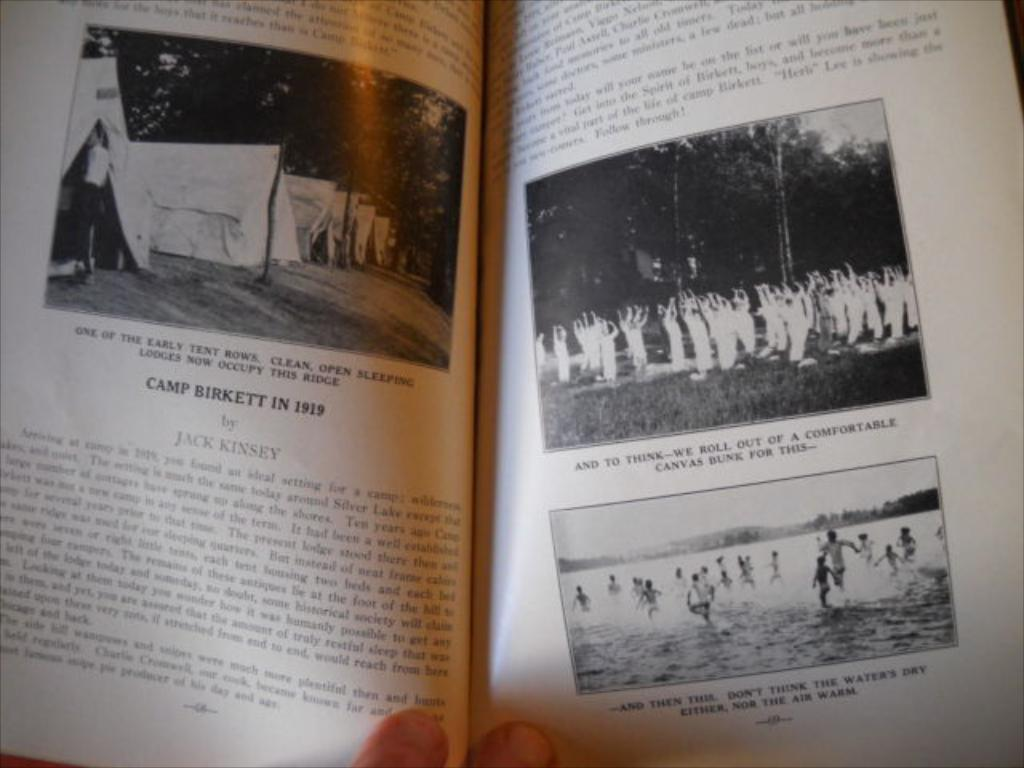Provide a one-sentence caption for the provided image. Pages from a book show the details of Camp Birkett in 1919. 